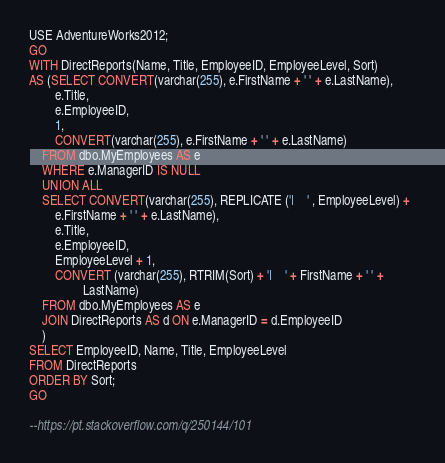<code> <loc_0><loc_0><loc_500><loc_500><_SQL_>USE AdventureWorks2012;  
GO  
WITH DirectReports(Name, Title, EmployeeID, EmployeeLevel, Sort)  
AS (SELECT CONVERT(varchar(255), e.FirstName + ' ' + e.LastName),  
        e.Title,  
        e.EmployeeID,  
        1,  
        CONVERT(varchar(255), e.FirstName + ' ' + e.LastName)  
    FROM dbo.MyEmployees AS e  
    WHERE e.ManagerID IS NULL  
    UNION ALL  
    SELECT CONVERT(varchar(255), REPLICATE ('|    ' , EmployeeLevel) +  
        e.FirstName + ' ' + e.LastName),  
        e.Title,  
        e.EmployeeID,  
        EmployeeLevel + 1,  
        CONVERT (varchar(255), RTRIM(Sort) + '|    ' + FirstName + ' ' +   
                 LastName)  
    FROM dbo.MyEmployees AS e  
    JOIN DirectReports AS d ON e.ManagerID = d.EmployeeID  
    )  
SELECT EmployeeID, Name, Title, EmployeeLevel  
FROM DirectReports   
ORDER BY Sort;  
GO

--https://pt.stackoverflow.com/q/250144/101
</code> 